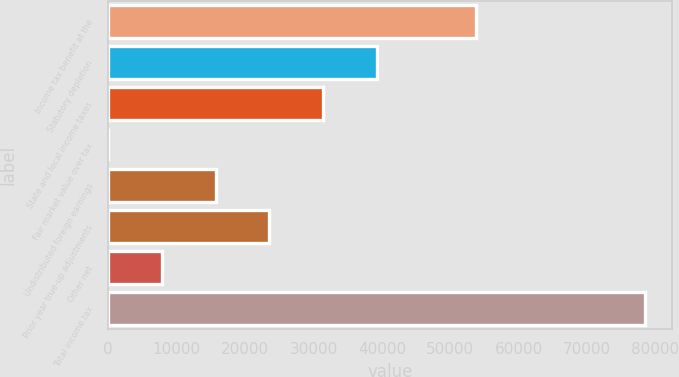<chart> <loc_0><loc_0><loc_500><loc_500><bar_chart><fcel>Income tax benefit at the<fcel>Statutory depletion<fcel>State and local income taxes<fcel>Fair market value over tax<fcel>Undistributed foreign earnings<fcel>Prior year true-up adjustments<fcel>Other net<fcel>Total income tax<nl><fcel>53809<fcel>39243.3<fcel>31395.3<fcel>3.57<fcel>15699.5<fcel>23547.4<fcel>7851.51<fcel>78483<nl></chart> 